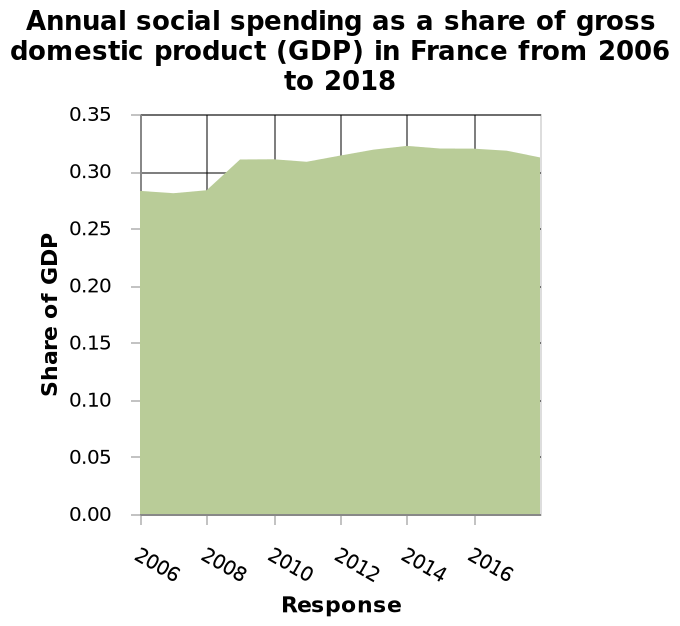<image>
What does the area plot show? The area plot shows the annual social spending as a share of gross domestic product (GDP) in France from 2006 to 2018. What is the range of years on the x-axis? The range of years on the x-axis is from 2006 to 2016. What is plotted on the x-axis? The x-axis plots the years from 2006 to 2016 as a linear scale. Has social spending increased in recent years?  No, social spending has neither increased nor decreased. Is there any relationship between social spending and key issues requiring changes?  There appears to be no relationship, as social spending has not changed despite the key issues. 